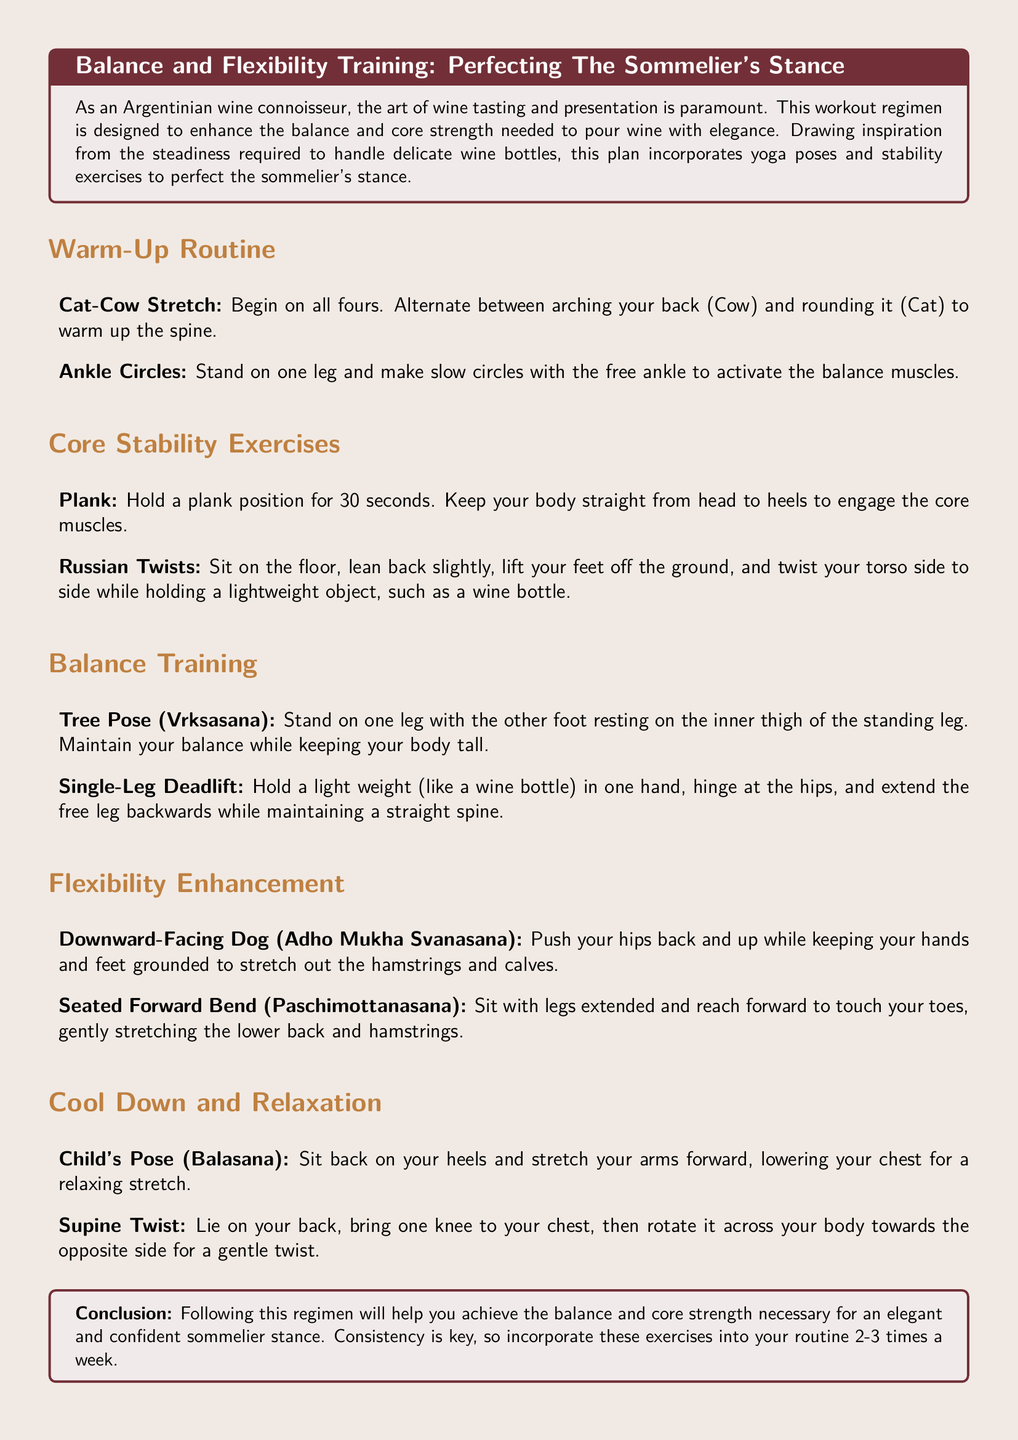What is the title of the workout plan? The title of the workout plan is specifically mentioned at the beginning of the document.
Answer: Perfecting The Sommelier's Stance How many core stability exercises are listed? The document lists two specific exercises under the core stability exercises section.
Answer: 2 What is one benefit of the workout regimen? The purpose of the document is to improve balance and core strength for wine pouring.
Answer: Balance and core strength What yoga pose is mentioned for flexibility enhancement? The document names two yoga poses under flexibility enhancement; one of them is specifically relevant.
Answer: Downward-Facing Dog How many times a week should the exercises be incorporated? The conclusion provides a specific recommendation for the frequency of the exercises.
Answer: 2-3 times What is the first warm-up exercise listed? The warm-up routine section begins with a specific exercise mentioned clearly.
Answer: Cat-Cow Stretch Which exercise involves a weight like a wine bottle? The core stability exercises include an exercise that specifically mentions a lightweight object related to wine.
Answer: Russian Twists What position should be held for 30 seconds in core stability? The document specifies a particular exercise duration and position to be maintained.
Answer: Plank 